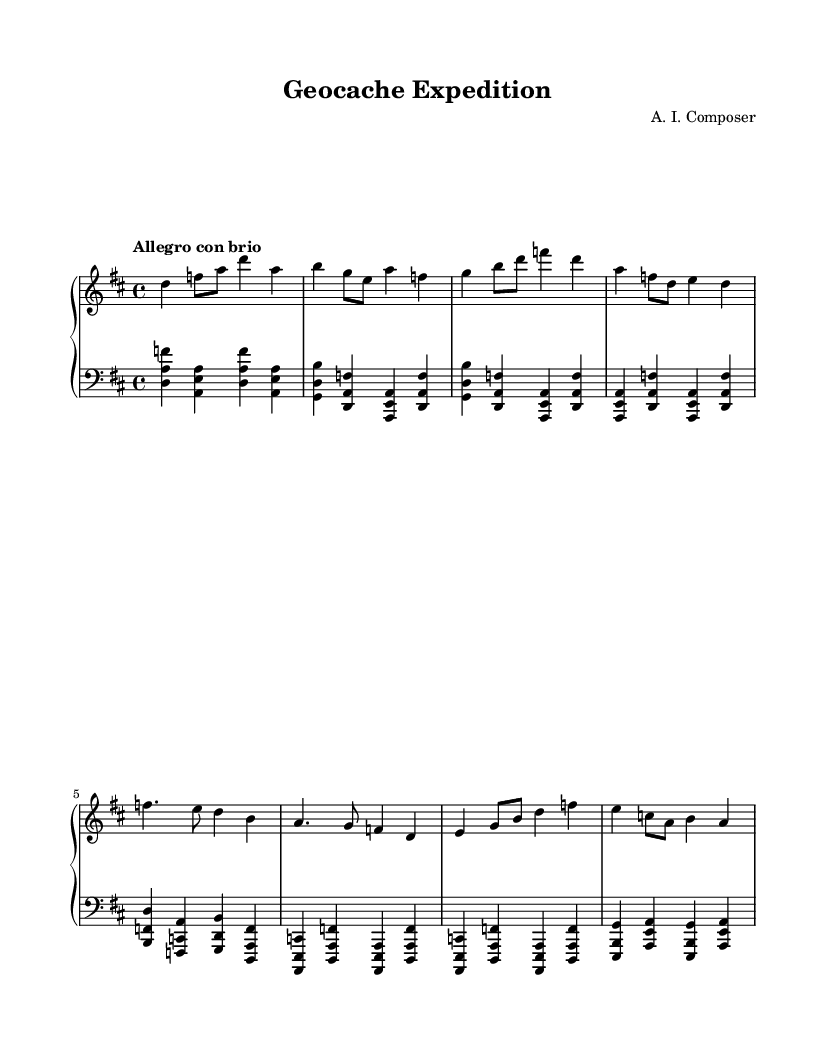What is the key signature of this music? The key signature is D major, which has two sharps: F# and C#. You can identify the key signature by looking at the beginning of the staff, where the sharps are placed.
Answer: D major What is the time signature of this music? The time signature is 4/4, which means there are four beats in a measure and the quarter note gets one beat. This is indicated at the beginning of the music, right after the key signature.
Answer: 4/4 What is the tempo marking of this music? The tempo marking is "Allegro con brio," which indicates a fast tempo with spirit. This can be found above the staff at the beginning of the piece, indicating how lively the music should be played.
Answer: Allegro con brio How many measures are in the right-hand part? There are 8 measures in the right-hand part, which can be counted by looking at the vertical lines that divide the music into sections. Each section represents one measure.
Answer: 8 What is the first note in the left-hand part? The first note in the left-hand part is D, which can be identified as the first note of the clef shown on the left-hand side and the first note played in the left-hand staff.
Answer: D How does the left-hand part compare to the right-hand in terms of range? The left-hand part generally plays lower notes compared to the right-hand part, which plays higher pitches. By examining the clefs, we see the left-hand is in the bass clef and the right-hand is in the treble clef, indicating the difference in pitch range.
Answer: Lower What type of composition is this music categorized as? This composition is categorized as a piano concerto, a genre characterized by its orchestral accompaniment and a solo piano part. The presence of dynamic interplay between the piano and any implied orchestration can also signify it as a concerto.
Answer: Piano concerto 